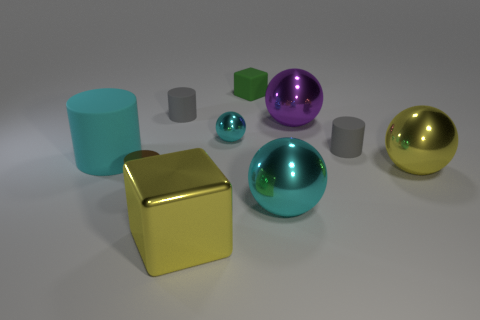Is the number of gray matte things that are to the left of the tiny metal cylinder greater than the number of gray rubber objects?
Offer a terse response. No. Are there any tiny metal spheres?
Your response must be concise. Yes. There is a cube that is behind the small sphere; what color is it?
Ensure brevity in your answer.  Green. There is a cyan cylinder that is the same size as the purple sphere; what is it made of?
Your response must be concise. Rubber. What number of other things are made of the same material as the big purple thing?
Provide a short and direct response. 5. There is a large object that is both to the right of the tiny brown cylinder and behind the yellow sphere; what is its color?
Provide a short and direct response. Purple. How many things are either big yellow metal objects that are on the left side of the green matte block or rubber cylinders?
Your response must be concise. 4. What number of other things are there of the same color as the large cylinder?
Provide a succinct answer. 2. Is the number of small rubber cylinders on the left side of the large matte object the same as the number of gray cubes?
Your answer should be very brief. Yes. There is a block behind the yellow metallic thing in front of the large yellow metal ball; how many gray objects are on the left side of it?
Make the answer very short. 1. 